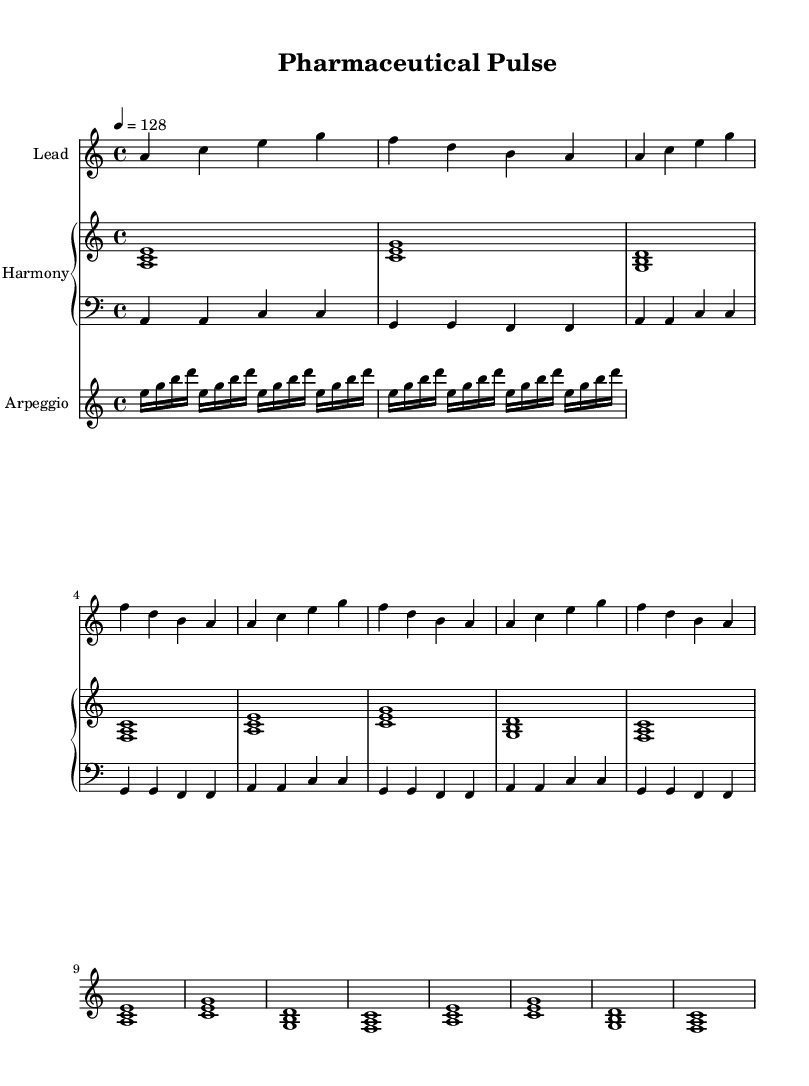What is the key signature of this music? The key signature shows the notes A, C, E, F, and G are present, which indicates the key of A minor.
Answer: A minor What is the time signature of this music? The time signature is represented by the fraction at the beginning of the score. It shows there are four beats in each measure and a quarter note receives one beat, which is indicated by 4/4.
Answer: 4/4 What is the tempo marking for this piece? The tempo marking is set at 128 beats per minute, as indicated by the tempo statement "4 = 128".
Answer: 128 How many measures are in the melody? The melody consists of a total of 12 measures, as we can count the separated groups of notes and repetitions.
Answer: 12 What patterns are used in the harmony? The harmony primarily uses sequences of triads (three-note chords) built on the scale notes, such as A minor, C major, G major, and F major, repeated over a section.
Answer: Triads What is a characteristic feature of the progression in this song? The progression in this music involves repeated use of established chords and rhythmic elements that is common in melodic progressive house music, serving to maintain focus and energy throughout.
Answer: Repetition What unique element does the arpeggio add to the composition? The arpeggio involves breaking down a chord into its individual notes played in a sequence, creating a flowing and melodic texture that complements the harmony and melody effectively.
Answer: Flow 